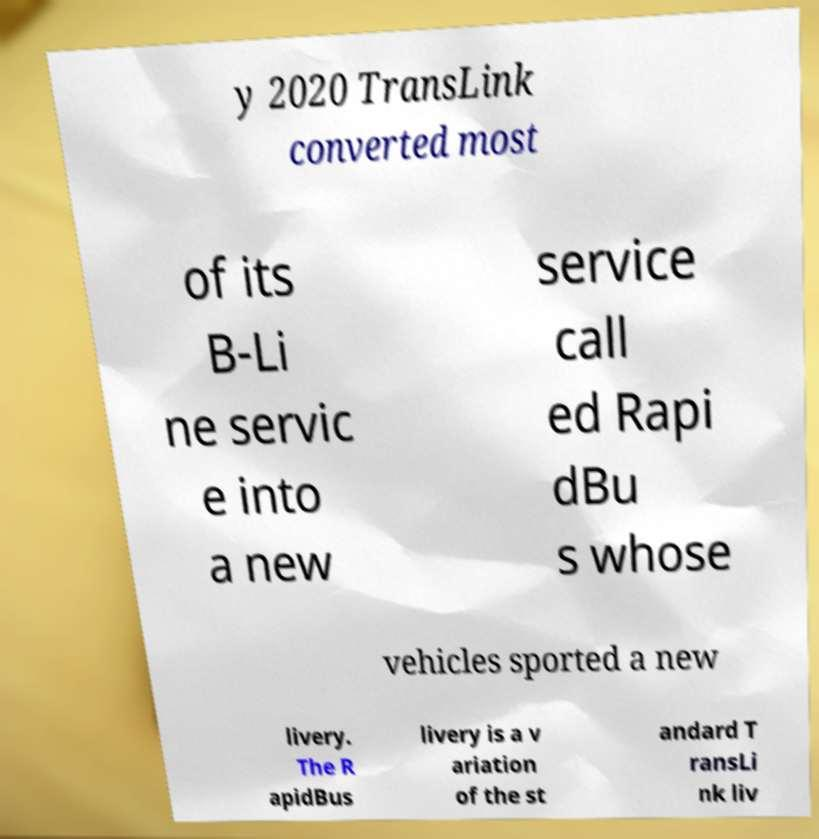There's text embedded in this image that I need extracted. Can you transcribe it verbatim? y 2020 TransLink converted most of its B-Li ne servic e into a new service call ed Rapi dBu s whose vehicles sported a new livery. The R apidBus livery is a v ariation of the st andard T ransLi nk liv 